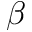<formula> <loc_0><loc_0><loc_500><loc_500>\beta</formula> 